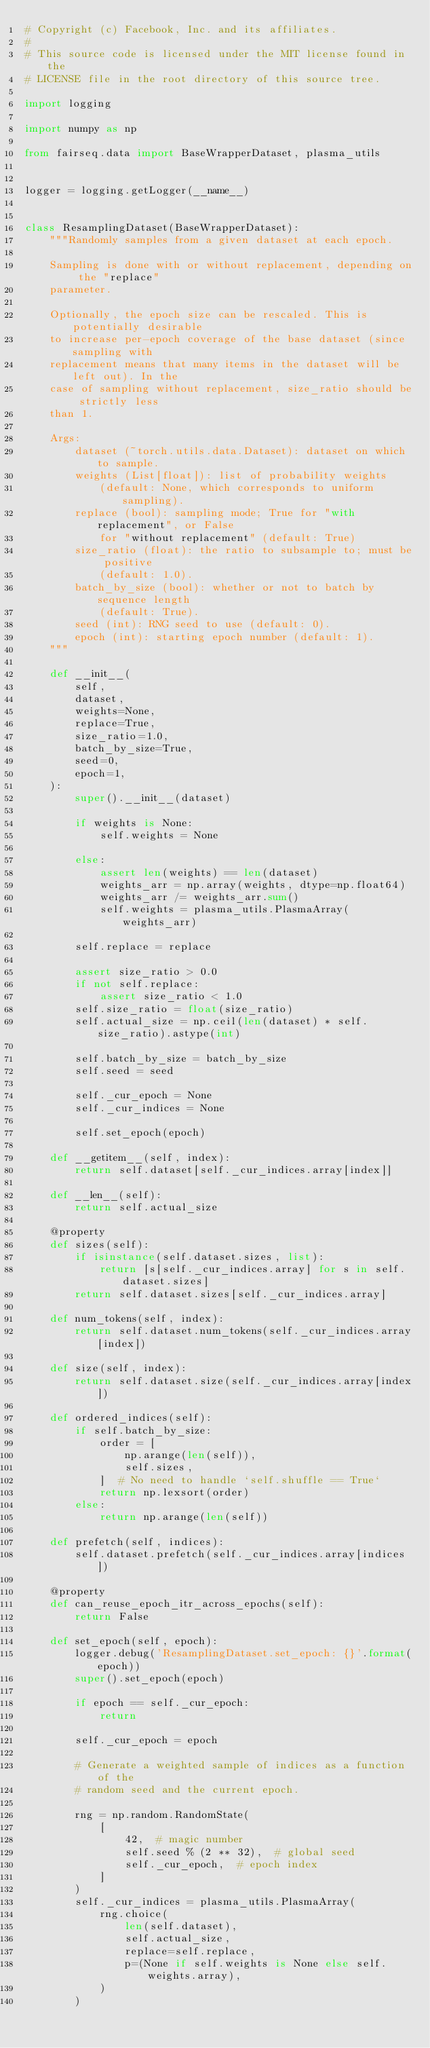<code> <loc_0><loc_0><loc_500><loc_500><_Python_># Copyright (c) Facebook, Inc. and its affiliates.
#
# This source code is licensed under the MIT license found in the
# LICENSE file in the root directory of this source tree.

import logging

import numpy as np

from fairseq.data import BaseWrapperDataset, plasma_utils


logger = logging.getLogger(__name__)


class ResamplingDataset(BaseWrapperDataset):
    """Randomly samples from a given dataset at each epoch.

    Sampling is done with or without replacement, depending on the "replace"
    parameter.

    Optionally, the epoch size can be rescaled. This is potentially desirable
    to increase per-epoch coverage of the base dataset (since sampling with
    replacement means that many items in the dataset will be left out). In the
    case of sampling without replacement, size_ratio should be strictly less
    than 1.

    Args:
        dataset (~torch.utils.data.Dataset): dataset on which to sample.
        weights (List[float]): list of probability weights
            (default: None, which corresponds to uniform sampling).
        replace (bool): sampling mode; True for "with replacement", or False
            for "without replacement" (default: True)
        size_ratio (float): the ratio to subsample to; must be positive
            (default: 1.0).
        batch_by_size (bool): whether or not to batch by sequence length
            (default: True).
        seed (int): RNG seed to use (default: 0).
        epoch (int): starting epoch number (default: 1).
    """

    def __init__(
        self,
        dataset,
        weights=None,
        replace=True,
        size_ratio=1.0,
        batch_by_size=True,
        seed=0,
        epoch=1,
    ):
        super().__init__(dataset)

        if weights is None:
            self.weights = None

        else:
            assert len(weights) == len(dataset)
            weights_arr = np.array(weights, dtype=np.float64)
            weights_arr /= weights_arr.sum()
            self.weights = plasma_utils.PlasmaArray(weights_arr)

        self.replace = replace

        assert size_ratio > 0.0
        if not self.replace:
            assert size_ratio < 1.0
        self.size_ratio = float(size_ratio)
        self.actual_size = np.ceil(len(dataset) * self.size_ratio).astype(int)

        self.batch_by_size = batch_by_size
        self.seed = seed

        self._cur_epoch = None
        self._cur_indices = None

        self.set_epoch(epoch)

    def __getitem__(self, index):
        return self.dataset[self._cur_indices.array[index]]

    def __len__(self):
        return self.actual_size

    @property
    def sizes(self):
        if isinstance(self.dataset.sizes, list):
            return [s[self._cur_indices.array] for s in self.dataset.sizes]
        return self.dataset.sizes[self._cur_indices.array]

    def num_tokens(self, index):
        return self.dataset.num_tokens(self._cur_indices.array[index])

    def size(self, index):
        return self.dataset.size(self._cur_indices.array[index])

    def ordered_indices(self):
        if self.batch_by_size:
            order = [
                np.arange(len(self)),
                self.sizes,
            ]  # No need to handle `self.shuffle == True`
            return np.lexsort(order)
        else:
            return np.arange(len(self))

    def prefetch(self, indices):
        self.dataset.prefetch(self._cur_indices.array[indices])

    @property
    def can_reuse_epoch_itr_across_epochs(self):
        return False

    def set_epoch(self, epoch):
        logger.debug('ResamplingDataset.set_epoch: {}'.format(epoch))
        super().set_epoch(epoch)

        if epoch == self._cur_epoch:
            return

        self._cur_epoch = epoch

        # Generate a weighted sample of indices as a function of the
        # random seed and the current epoch.

        rng = np.random.RandomState(
            [
                42,  # magic number
                self.seed % (2 ** 32),  # global seed
                self._cur_epoch,  # epoch index
            ]
        )
        self._cur_indices = plasma_utils.PlasmaArray(
            rng.choice(
                len(self.dataset),
                self.actual_size,
                replace=self.replace,
                p=(None if self.weights is None else self.weights.array),
            )
        )
</code> 